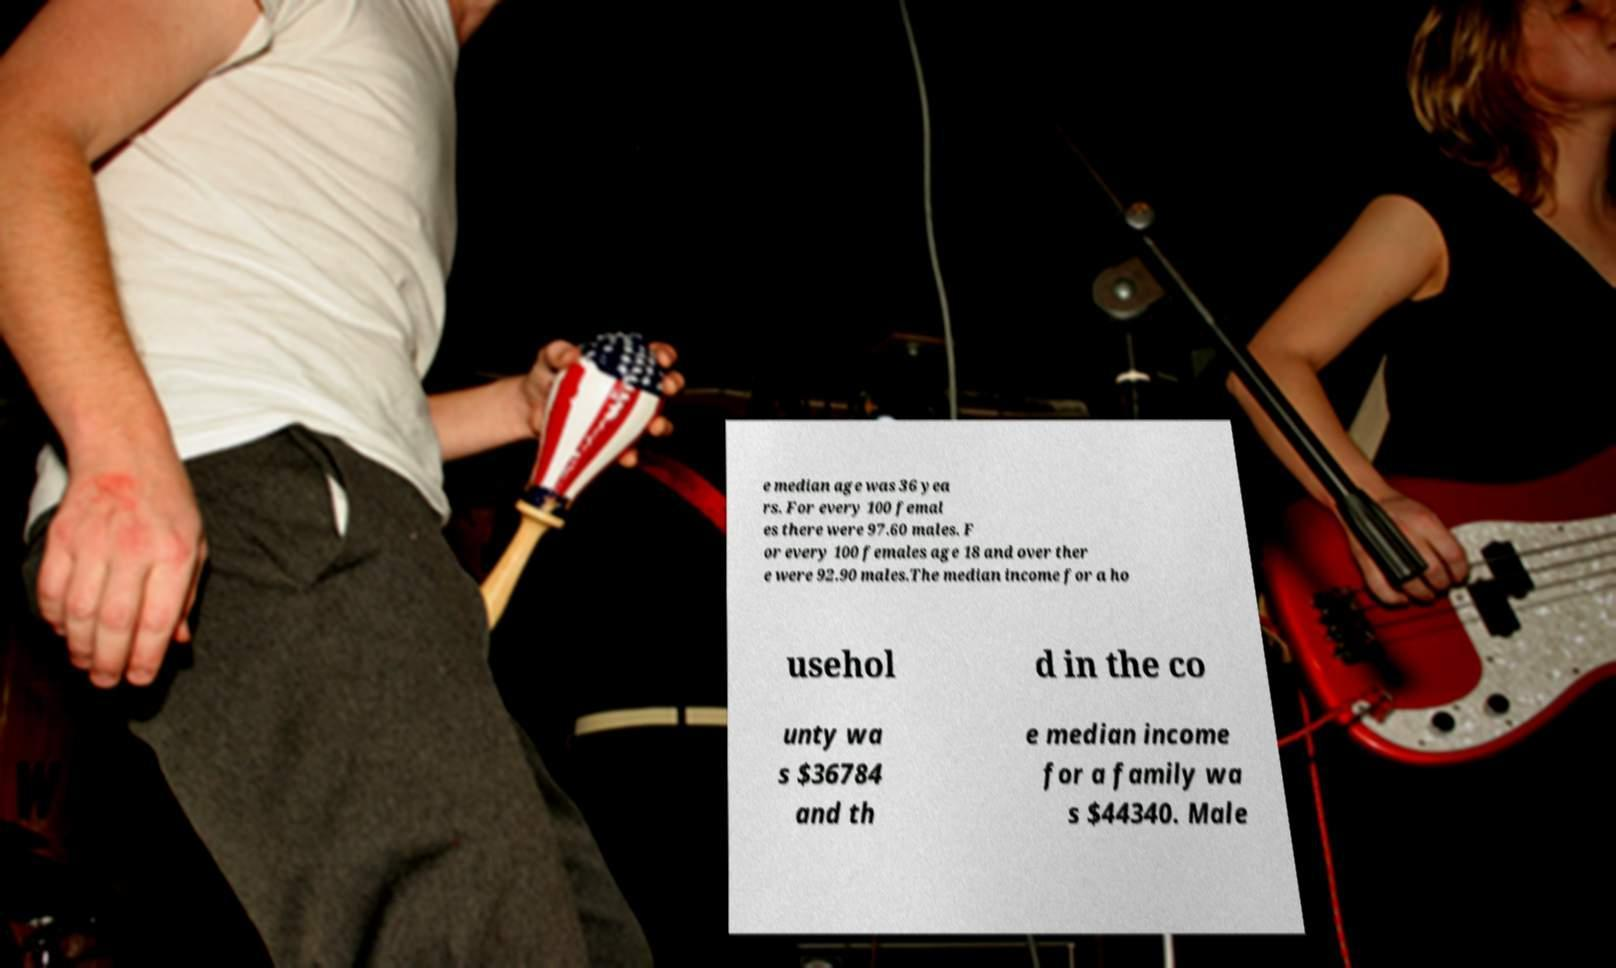Please read and relay the text visible in this image. What does it say? e median age was 36 yea rs. For every 100 femal es there were 97.60 males. F or every 100 females age 18 and over ther e were 92.90 males.The median income for a ho usehol d in the co unty wa s $36784 and th e median income for a family wa s $44340. Male 